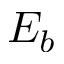Convert formula to latex. <formula><loc_0><loc_0><loc_500><loc_500>E _ { b }</formula> 